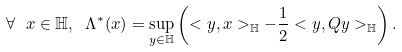Convert formula to latex. <formula><loc_0><loc_0><loc_500><loc_500>\forall \ x \in \mathbb { H } , \ \Lambda ^ { \ast } ( x ) = \underset { y \in \mathbb { H } } { \sup } \left ( < y , x > _ { \mathbb { H } } - \frac { 1 } { 2 } < y , Q y > _ { \mathbb { H } } \right ) . \ \</formula> 